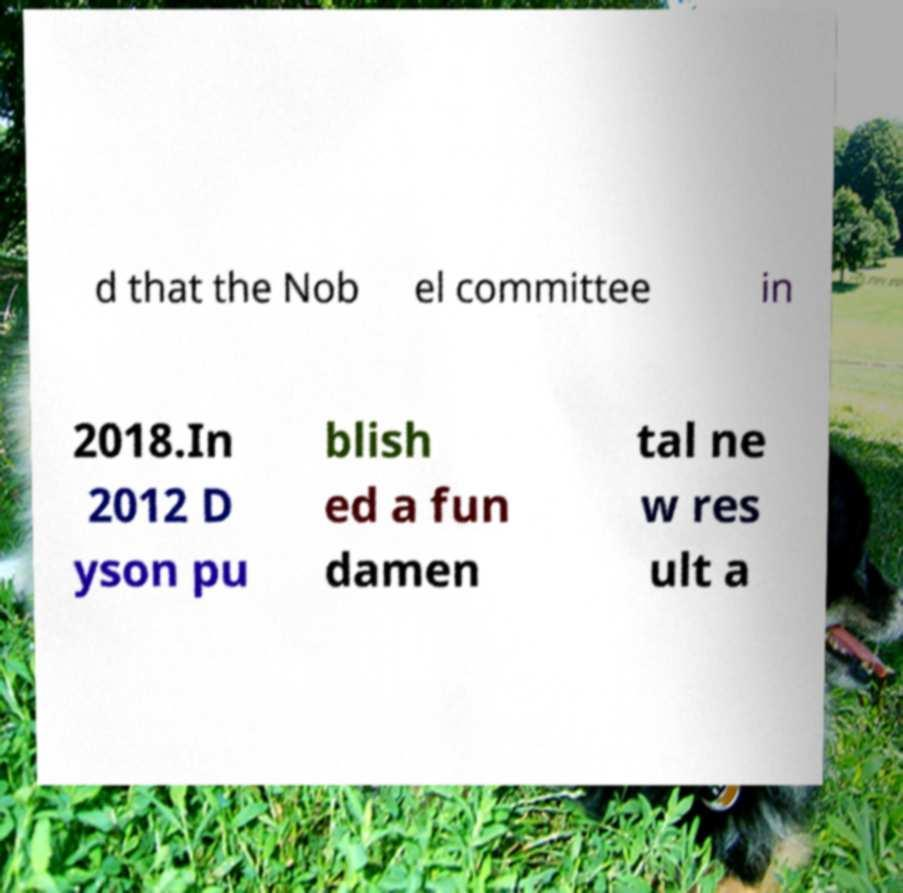Can you accurately transcribe the text from the provided image for me? d that the Nob el committee in 2018.In 2012 D yson pu blish ed a fun damen tal ne w res ult a 